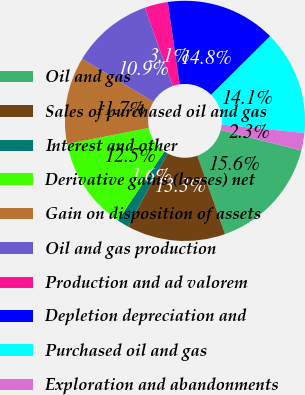Convert chart. <chart><loc_0><loc_0><loc_500><loc_500><pie_chart><fcel>Oil and gas<fcel>Sales of purchased oil and gas<fcel>Interest and other<fcel>Derivative gains (losses) net<fcel>Gain on disposition of assets<fcel>Oil and gas production<fcel>Production and ad valorem<fcel>Depletion depreciation and<fcel>Purchased oil and gas<fcel>Exploration and abandonments<nl><fcel>15.62%<fcel>13.28%<fcel>1.57%<fcel>12.5%<fcel>11.72%<fcel>10.94%<fcel>3.13%<fcel>14.84%<fcel>14.06%<fcel>2.35%<nl></chart> 